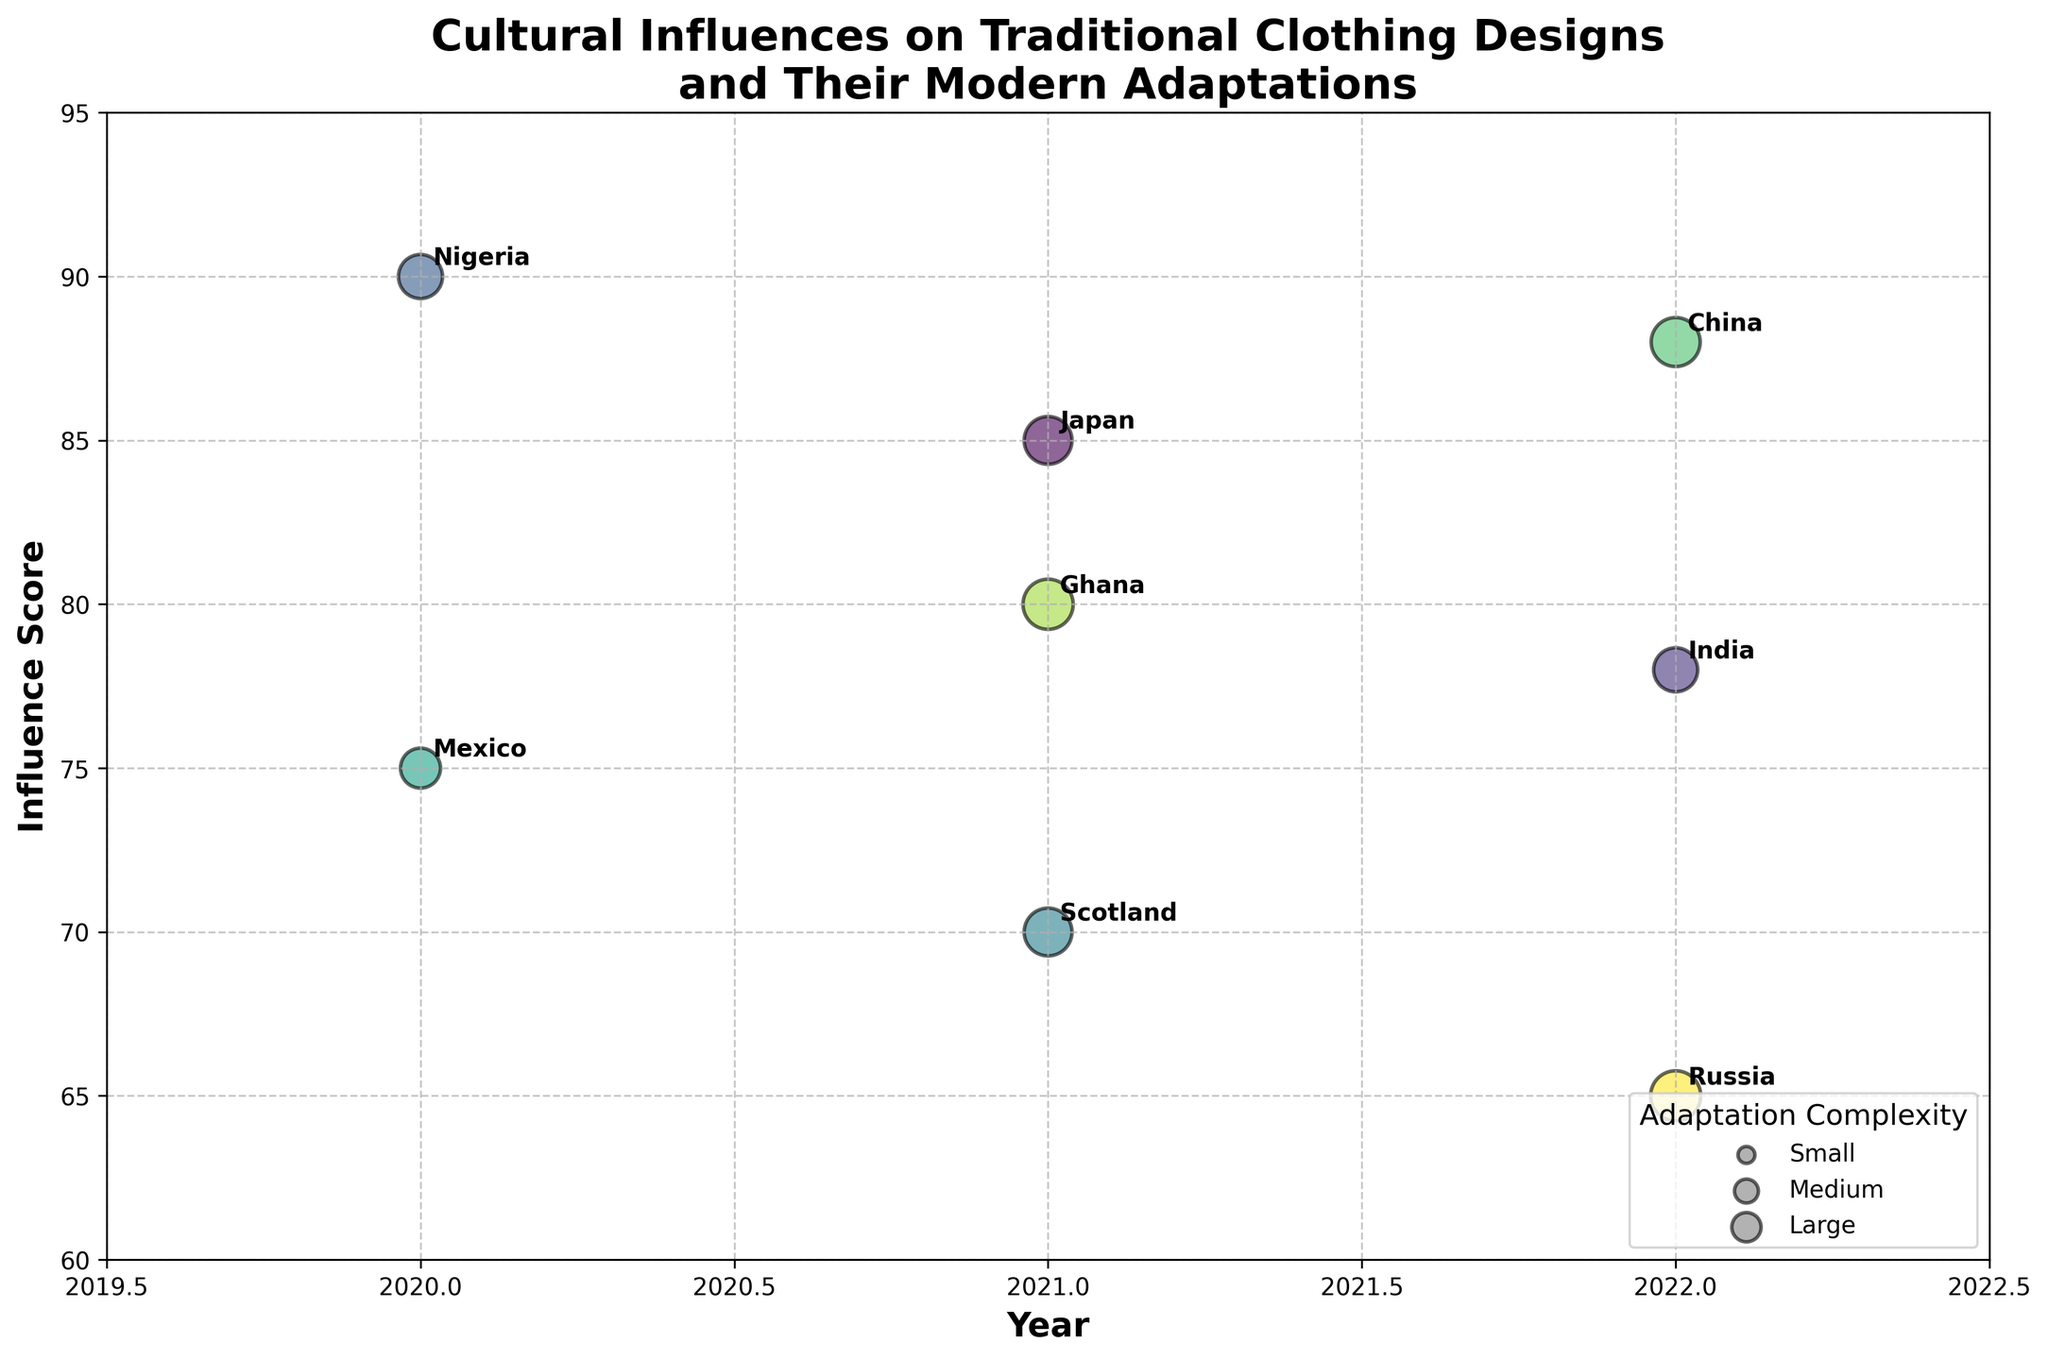what is the highest influence score in the figure? The influence scores can be assessed based on the "Influence Score" axis. The highest influence score shown is for Nigeria with Ankara Streetwear having an influence score of 90.
Answer: 90 Which traditional clothing design and modern adaptation has the influence score of 78? To find the traditional clothing design and its modern adaptation with an influence score of 78, you need to identify the corresponding data point. India with Fusion Sari Gowns has an influence score of 78.
Answer: Sari and Fusion Sari Gowns What is the average influence score of the traditional and modern clothing adaptations in the year 2021? First, identify the influence scores for the year 2021: Japan (85), Scotland (70), and Ghana (80). Sum these values (85 + 70 + 80 = 235) and divide by the number of entries (235 / 3). The average influence score for 2021 is 78.33.
Answer: 78.33 Which country has the lowest influence score and what is that score? The lowest influence score can be identified by looking at the "Influence Score" axis. Russia with Modern Sarafan Blouses has the lowest score of 65.
Answer: Russia, 65 What is the range of the influence scores for the year 2022? To find the range, identify the highest and lowest scores for 2022. China (88) and India (78) are from 2022. Subtract the lowest score from the highest score (88 - 78), resulting in a range of 10.
Answer: 10 How many bubble sizes (adaptation complexities) are given in the legend and what are they? The legend provides three different bubble sizes representing adaptation complexities: Small, Medium, and Large.
Answer: 3, Small, Medium, Large Is there a traditional clothing design from the same country that appears in different years? Based on the country labels and years on the "Year" axis, no country has a traditional clothing design that appears in different years.
Answer: No Which modern adaptation has the largest bubble and what does this size represent? The largest bubble size can be identified by comparing bubble sizes. China with Modern Cheongsam Tops has the largest bubble, representing a higher adaptation complexity.
Answer: Modern Cheongsam Tops, Largest adaptation complexity Which country has both the highest and the lowest influence scores? By examining the scores, Nigeria has the highest influence score with 90, while Russia has the lowest with 65.
Answer: Nigeria with the highest, Russia with the lowest 